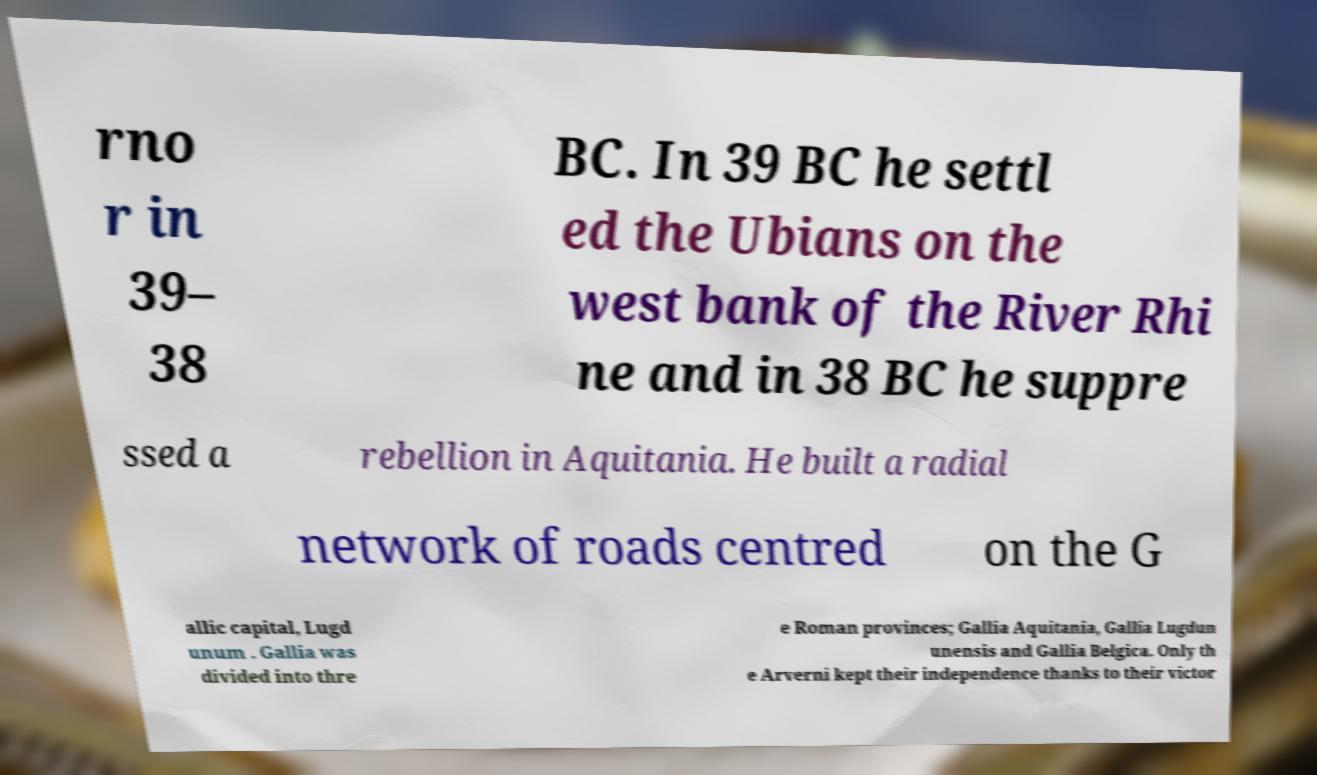Can you accurately transcribe the text from the provided image for me? rno r in 39– 38 BC. In 39 BC he settl ed the Ubians on the west bank of the River Rhi ne and in 38 BC he suppre ssed a rebellion in Aquitania. He built a radial network of roads centred on the G allic capital, Lugd unum . Gallia was divided into thre e Roman provinces; Gallia Aquitania, Gallia Lugdun unensis and Gallia Belgica. Only th e Arverni kept their independence thanks to their victor 